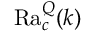<formula> <loc_0><loc_0><loc_500><loc_500>R a _ { c } ^ { Q } ( k )</formula> 